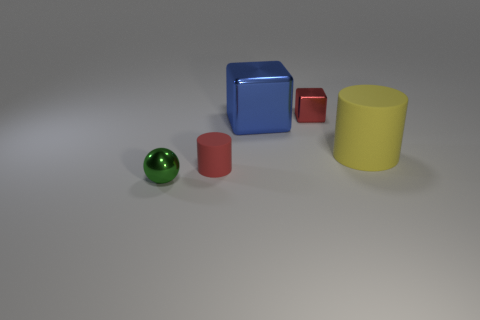What color is the big cylinder that is the same material as the small red cylinder?
Make the answer very short. Yellow. Are the small red cube and the cylinder on the right side of the red shiny thing made of the same material?
Keep it short and to the point. No. The big cylinder is what color?
Offer a terse response. Yellow. What size is the blue cube that is the same material as the red cube?
Your response must be concise. Large. There is a metal cube in front of the red thing that is on the right side of the small cylinder; what number of big cubes are to the right of it?
Ensure brevity in your answer.  0. There is a small cylinder; does it have the same color as the small metal thing in front of the large yellow matte object?
Offer a very short reply. No. What is the shape of the small object that is the same color as the tiny cylinder?
Provide a short and direct response. Cube. What material is the tiny thing right of the cylinder that is left of the tiny red object behind the tiny red rubber cylinder made of?
Offer a very short reply. Metal. There is a rubber object that is to the right of the big blue cube; does it have the same shape as the small green object?
Ensure brevity in your answer.  No. There is a large yellow object that is on the right side of the tiny matte cylinder; what material is it?
Give a very brief answer. Rubber. 